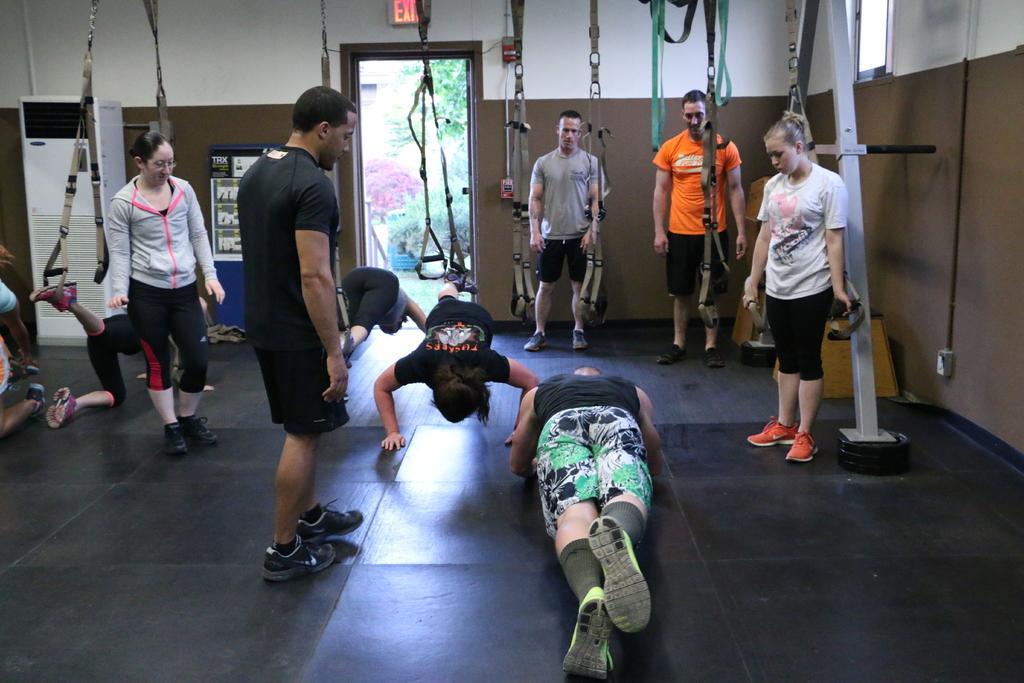How would you summarize this image in a sentence or two? In the picture I can see people among the some are standing and some are doing exercises on the floor. I can also see some objects hanging to the ceiling. In the background I can see a wall, door, trees and other objects. 